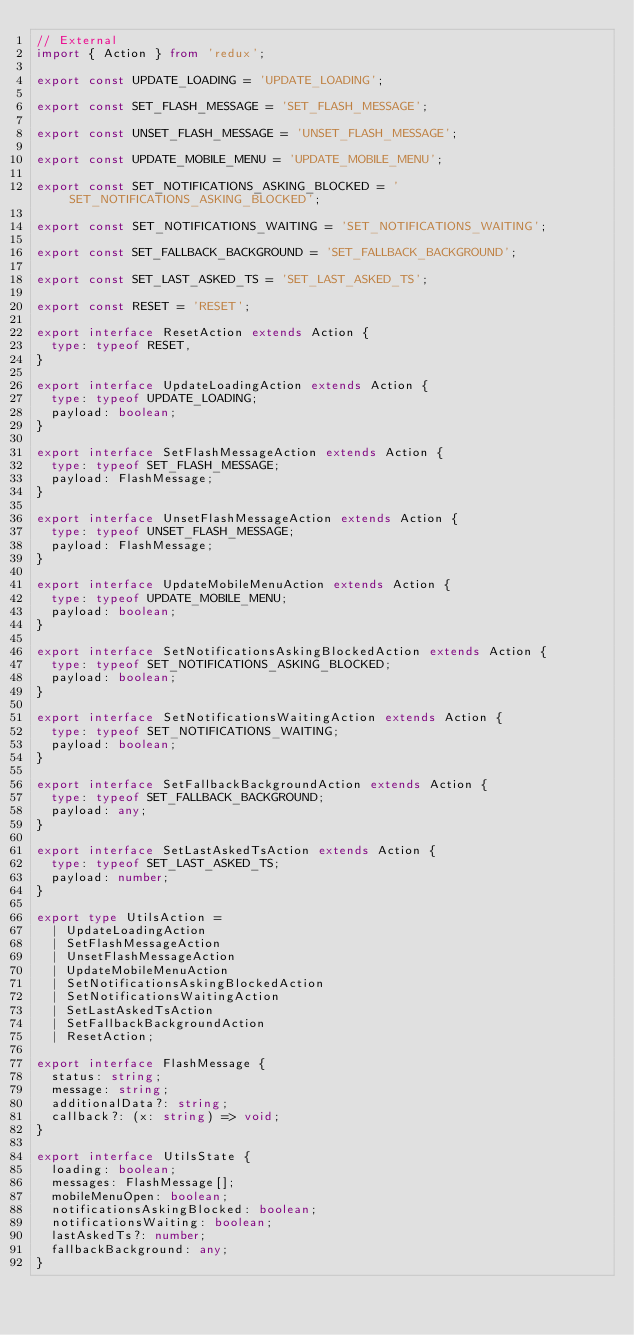Convert code to text. <code><loc_0><loc_0><loc_500><loc_500><_TypeScript_>// External
import { Action } from 'redux';

export const UPDATE_LOADING = 'UPDATE_LOADING';

export const SET_FLASH_MESSAGE = 'SET_FLASH_MESSAGE';

export const UNSET_FLASH_MESSAGE = 'UNSET_FLASH_MESSAGE';

export const UPDATE_MOBILE_MENU = 'UPDATE_MOBILE_MENU';

export const SET_NOTIFICATIONS_ASKING_BLOCKED = 'SET_NOTIFICATIONS_ASKING_BLOCKED';

export const SET_NOTIFICATIONS_WAITING = 'SET_NOTIFICATIONS_WAITING';

export const SET_FALLBACK_BACKGROUND = 'SET_FALLBACK_BACKGROUND';

export const SET_LAST_ASKED_TS = 'SET_LAST_ASKED_TS';

export const RESET = 'RESET';

export interface ResetAction extends Action {
  type: typeof RESET,
}

export interface UpdateLoadingAction extends Action {
  type: typeof UPDATE_LOADING;
  payload: boolean;
}

export interface SetFlashMessageAction extends Action {
  type: typeof SET_FLASH_MESSAGE;
  payload: FlashMessage;
}

export interface UnsetFlashMessageAction extends Action {
  type: typeof UNSET_FLASH_MESSAGE;
  payload: FlashMessage;
}

export interface UpdateMobileMenuAction extends Action {
  type: typeof UPDATE_MOBILE_MENU;
  payload: boolean;
}

export interface SetNotificationsAskingBlockedAction extends Action {
  type: typeof SET_NOTIFICATIONS_ASKING_BLOCKED;
  payload: boolean;
}

export interface SetNotificationsWaitingAction extends Action {
  type: typeof SET_NOTIFICATIONS_WAITING;
  payload: boolean;
}

export interface SetFallbackBackgroundAction extends Action {
  type: typeof SET_FALLBACK_BACKGROUND;
  payload: any;
}

export interface SetLastAskedTsAction extends Action {
  type: typeof SET_LAST_ASKED_TS;
  payload: number;
}

export type UtilsAction =
  | UpdateLoadingAction
  | SetFlashMessageAction
  | UnsetFlashMessageAction
  | UpdateMobileMenuAction
  | SetNotificationsAskingBlockedAction
  | SetNotificationsWaitingAction
  | SetLastAskedTsAction
  | SetFallbackBackgroundAction
  | ResetAction;

export interface FlashMessage {
  status: string;
  message: string;
  additionalData?: string;
  callback?: (x: string) => void;
}

export interface UtilsState {
  loading: boolean;
  messages: FlashMessage[];
  mobileMenuOpen: boolean;
  notificationsAskingBlocked: boolean;
  notificationsWaiting: boolean;
  lastAskedTs?: number;
  fallbackBackground: any;
}
</code> 